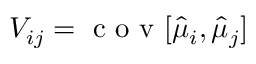Convert formula to latex. <formula><loc_0><loc_0><loc_500><loc_500>V _ { i j } = c o v [ \hat { \mu } _ { i } , \hat { \mu } _ { j } ]</formula> 